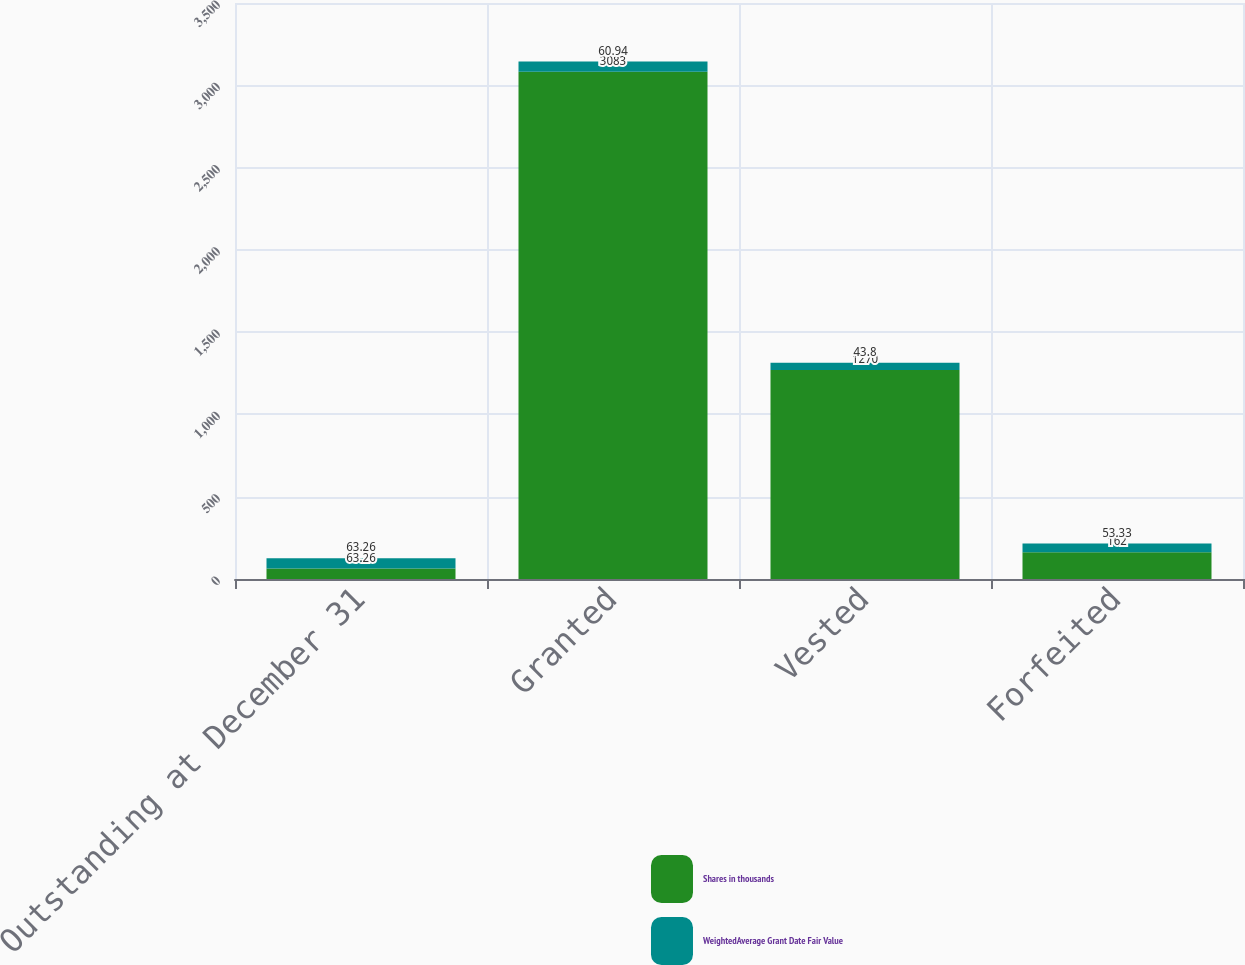<chart> <loc_0><loc_0><loc_500><loc_500><stacked_bar_chart><ecel><fcel>Outstanding at December 31<fcel>Granted<fcel>Vested<fcel>Forfeited<nl><fcel>Shares in thousands<fcel>63.26<fcel>3083<fcel>1270<fcel>162<nl><fcel>WeightedAverage Grant Date Fair Value<fcel>63.26<fcel>60.94<fcel>43.8<fcel>53.33<nl></chart> 